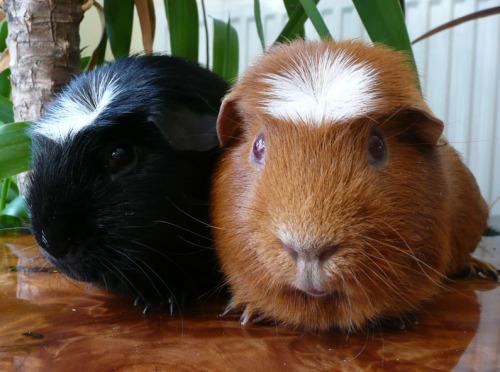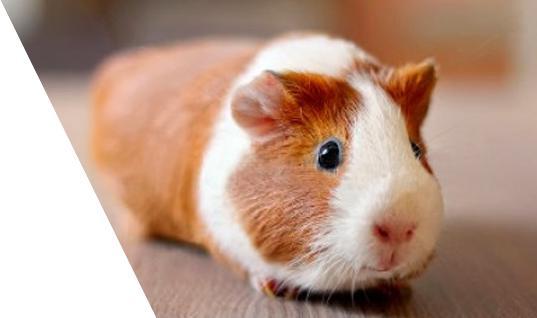The first image is the image on the left, the second image is the image on the right. Evaluate the accuracy of this statement regarding the images: "There is no brown fur on these guinea pigs.". Is it true? Answer yes or no. No. 